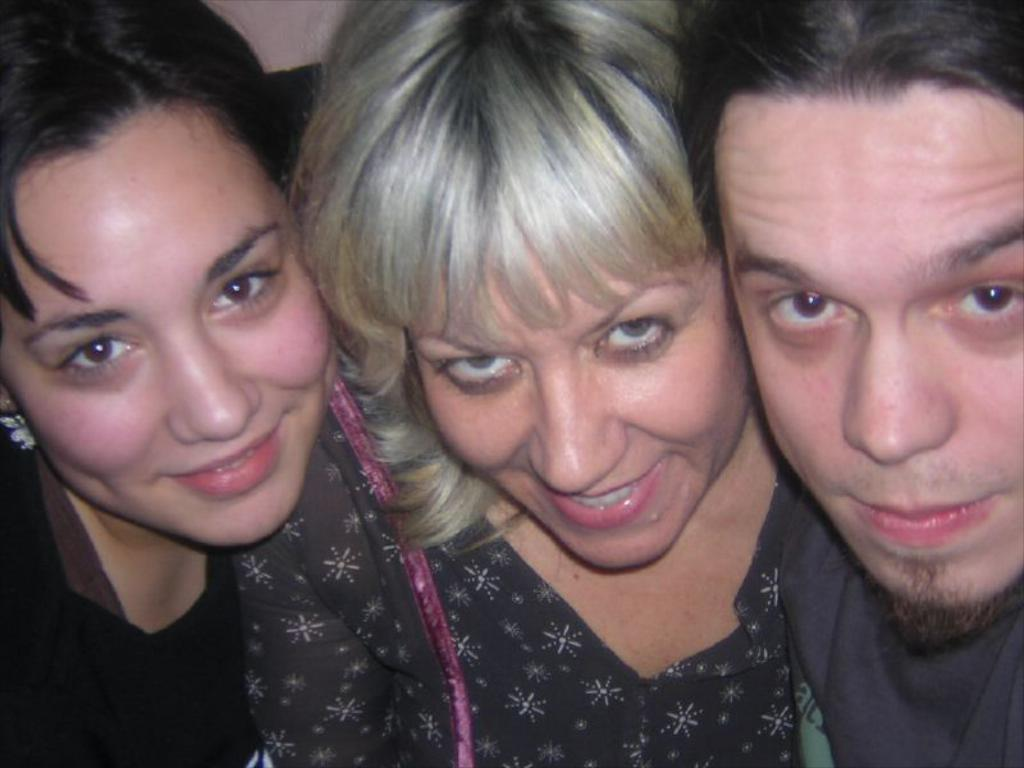What is the main focus of the image? The main focus of the image is the people in the center. Can you describe the people in the image? Unfortunately, the provided facts do not give any details about the people in the image. Are there any other elements in the image besides the people? The provided facts do not mention any other elements in the image. What type of map is being used by the people in the image? There is no map present in the image. What is the temperature like during the summer in the image? The provided facts do not mention any information about the temperature or season in the image. 